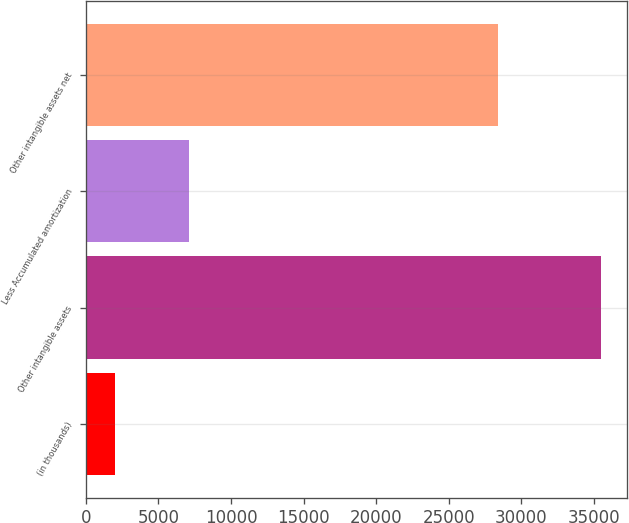Convert chart. <chart><loc_0><loc_0><loc_500><loc_500><bar_chart><fcel>(in thousands)<fcel>Other intangible assets<fcel>Less Accumulated amortization<fcel>Other intangible assets net<nl><fcel>2012<fcel>35515<fcel>7126<fcel>28389<nl></chart> 